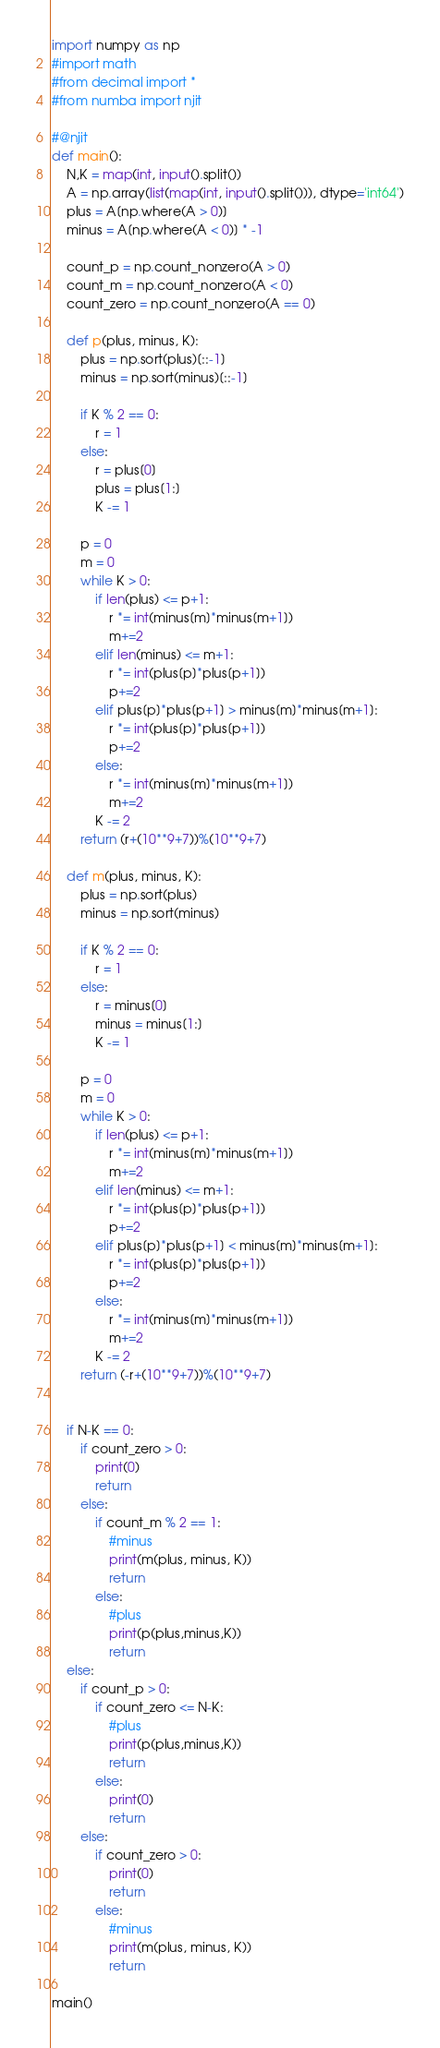<code> <loc_0><loc_0><loc_500><loc_500><_Python_>import numpy as np
#import math
#from decimal import *
#from numba import njit

#@njit
def main():
    N,K = map(int, input().split())
    A = np.array(list(map(int, input().split())), dtype='int64')
    plus = A[np.where(A > 0)]
    minus = A[np.where(A < 0)] * -1
    
    count_p = np.count_nonzero(A > 0)
    count_m = np.count_nonzero(A < 0)
    count_zero = np.count_nonzero(A == 0)

    def p(plus, minus, K):
        plus = np.sort(plus)[::-1]
        minus = np.sort(minus)[::-1]

        if K % 2 == 0:
            r = 1
        else:
            r = plus[0]
            plus = plus[1:]
            K -= 1
        
        p = 0
        m = 0
        while K > 0:
            if len(plus) <= p+1:
                r *= int(minus[m]*minus[m+1])
                m+=2
            elif len(minus) <= m+1:
                r *= int(plus[p]*plus[p+1])
                p+=2
            elif plus[p]*plus[p+1] > minus[m]*minus[m+1]:
                r *= int(plus[p]*plus[p+1])
                p+=2
            else:
                r *= int(minus[m]*minus[m+1])
                m+=2
            K -= 2
        return (r+(10**9+7))%(10**9+7)
            
    def m(plus, minus, K):
        plus = np.sort(plus)
        minus = np.sort(minus)

        if K % 2 == 0:
            r = 1
        else:
            r = minus[0]
            minus = minus[1:]
            K -= 1

        p = 0
        m = 0
        while K > 0:
            if len(plus) <= p+1:
                r *= int(minus[m]*minus[m+1])
                m+=2
            elif len(minus) <= m+1:
                r *= int(plus[p]*plus[p+1])
                p+=2
            elif plus[p]*plus[p+1] < minus[m]*minus[m+1]:
                r *= int(plus[p]*plus[p+1])
                p+=2
            else:
                r *= int(minus[m]*minus[m+1])
                m+=2
            K -= 2
        return (-r+(10**9+7))%(10**9+7)
            
    
    if N-K == 0:
        if count_zero > 0:
            print(0)
            return
        else:
            if count_m % 2 == 1:
                #minus
                print(m(plus, minus, K))
                return
            else:
                #plus
                print(p(plus,minus,K))
                return
    else:
        if count_p > 0:
            if count_zero <= N-K:
                #plus
                print(p(plus,minus,K))
                return
            else:
                print(0)
                return
        else:
            if count_zero > 0:
                print(0)
                return
            else:
                #minus
                print(m(plus, minus, K))
                return

main()
</code> 